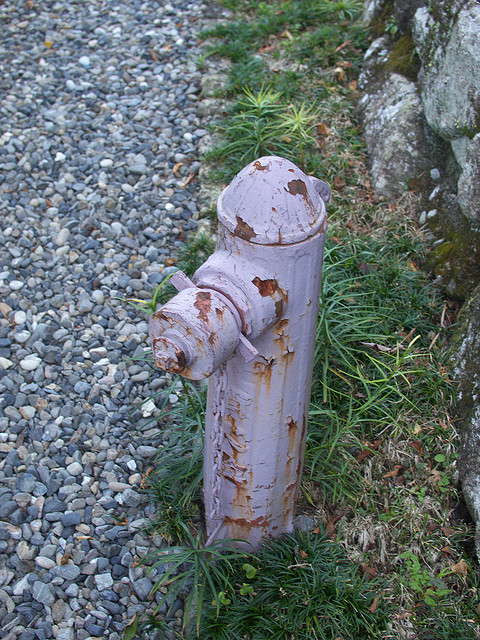If the weather around the fireplug suddenly changed drastically, how might it affect the scene? If the weather around the fireplug were to change drastically, it could dramatically alter the scene. For example, if it began to rain heavily, the damp conditions might make the colors more vibrant and bring out the detail in the chipped paint and rusty spots. The gray pebbles might shine with wetness, and small puddles could form around the fireplug. If it snowed, the hydrant might stand as a colorful contrast against the white blanket, with frosty layers accentuating its rough texture. Alternatively, in extreme heat, the paint might flake off further, and the vegetation around might wither, giving the area a more desolate appearance. 